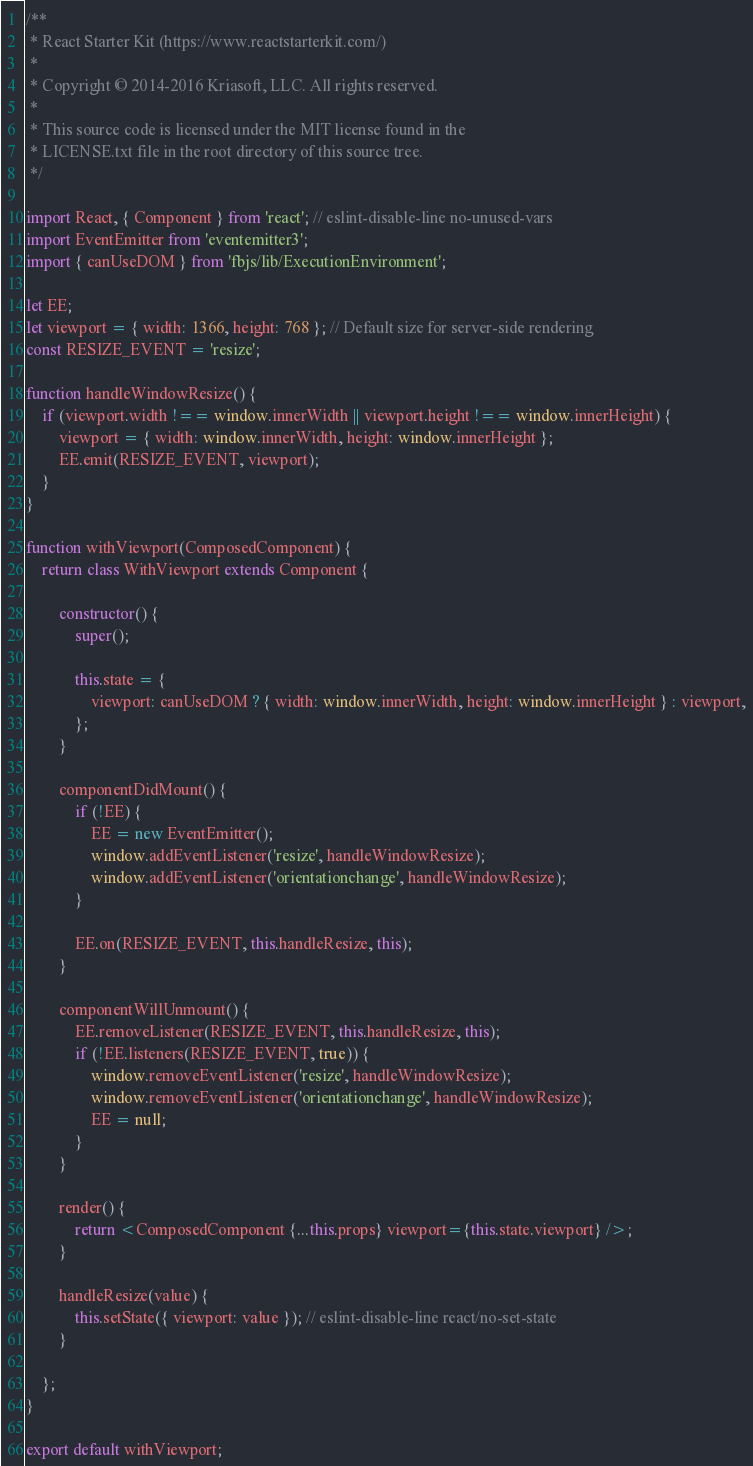<code> <loc_0><loc_0><loc_500><loc_500><_JavaScript_>/**
 * React Starter Kit (https://www.reactstarterkit.com/)
 *
 * Copyright © 2014-2016 Kriasoft, LLC. All rights reserved.
 *
 * This source code is licensed under the MIT license found in the
 * LICENSE.txt file in the root directory of this source tree.
 */

import React, { Component } from 'react'; // eslint-disable-line no-unused-vars
import EventEmitter from 'eventemitter3';
import { canUseDOM } from 'fbjs/lib/ExecutionEnvironment';

let EE;
let viewport = { width: 1366, height: 768 }; // Default size for server-side rendering
const RESIZE_EVENT = 'resize';

function handleWindowResize() {
    if (viewport.width !== window.innerWidth || viewport.height !== window.innerHeight) {
        viewport = { width: window.innerWidth, height: window.innerHeight };
        EE.emit(RESIZE_EVENT, viewport);
    }
}

function withViewport(ComposedComponent) {
    return class WithViewport extends Component {

        constructor() {
            super();

            this.state = {
                viewport: canUseDOM ? { width: window.innerWidth, height: window.innerHeight } : viewport,
            };
        }

        componentDidMount() {
            if (!EE) {
                EE = new EventEmitter();
                window.addEventListener('resize', handleWindowResize);
                window.addEventListener('orientationchange', handleWindowResize);
            }

            EE.on(RESIZE_EVENT, this.handleResize, this);
        }

        componentWillUnmount() {
            EE.removeListener(RESIZE_EVENT, this.handleResize, this);
            if (!EE.listeners(RESIZE_EVENT, true)) {
                window.removeEventListener('resize', handleWindowResize);
                window.removeEventListener('orientationchange', handleWindowResize);
                EE = null;
            }
        }

        render() {
            return <ComposedComponent {...this.props} viewport={this.state.viewport} />;
        }

        handleResize(value) {
            this.setState({ viewport: value }); // eslint-disable-line react/no-set-state
        }

    };
}

export default withViewport;
</code> 